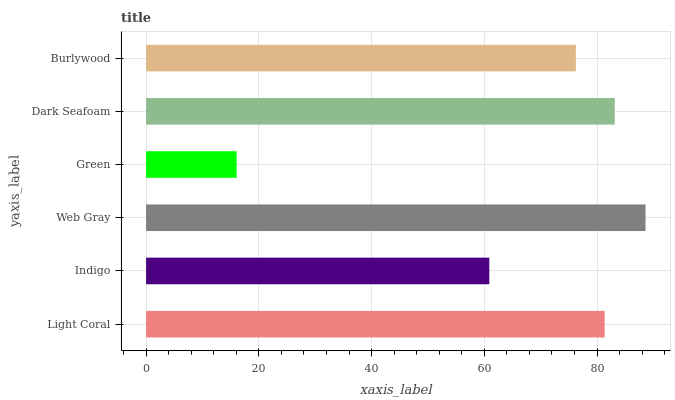Is Green the minimum?
Answer yes or no. Yes. Is Web Gray the maximum?
Answer yes or no. Yes. Is Indigo the minimum?
Answer yes or no. No. Is Indigo the maximum?
Answer yes or no. No. Is Light Coral greater than Indigo?
Answer yes or no. Yes. Is Indigo less than Light Coral?
Answer yes or no. Yes. Is Indigo greater than Light Coral?
Answer yes or no. No. Is Light Coral less than Indigo?
Answer yes or no. No. Is Light Coral the high median?
Answer yes or no. Yes. Is Burlywood the low median?
Answer yes or no. Yes. Is Dark Seafoam the high median?
Answer yes or no. No. Is Light Coral the low median?
Answer yes or no. No. 